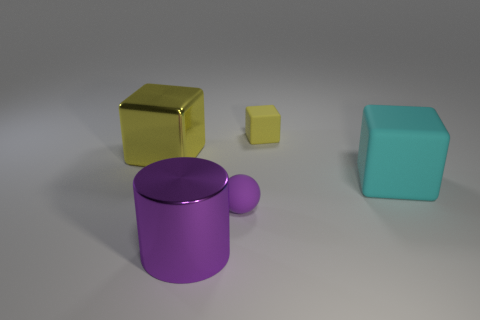Add 5 cyan blocks. How many objects exist? 10 Subtract all balls. How many objects are left? 4 Add 2 small yellow blocks. How many small yellow blocks are left? 3 Add 2 tiny green rubber objects. How many tiny green rubber objects exist? 2 Subtract 0 green cubes. How many objects are left? 5 Subtract all small purple balls. Subtract all tiny rubber objects. How many objects are left? 2 